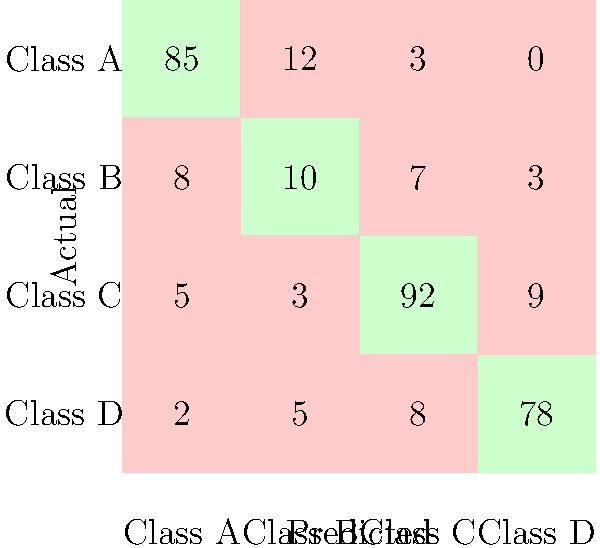As an efficiency-focused software engineer, you're evaluating a multi-class classification model for a critical system component. Given the confusion matrix above, calculate the model's macro-averaged F1 score to assess its overall performance across all classes. How would this metric help in deciding whether to integrate this model or develop a more efficient alternative? To calculate the macro-averaged F1 score, we'll follow these steps:

1. Calculate precision and recall for each class:

Class A:
Precision = 85 / (85 + 12 + 3 + 0) = 0.85
Recall = 85 / (85 + 8 + 5 + 2) = 0.85

Class B:
Precision = 10 / (8 + 10 + 7 + 3) = 0.357
Recall = 10 / (12 + 10 + 3 + 5) = 0.333

Class C:
Precision = 92 / (5 + 3 + 92 + 9) = 0.844
Recall = 92 / (3 + 7 + 92 + 8) = 0.836

Class D:
Precision = 78 / (2 + 5 + 8 + 78) = 0.839
Recall = 78 / (0 + 3 + 9 + 78) = 0.867

2. Calculate F1 score for each class:
F1 = 2 * (Precision * Recall) / (Precision + Recall)

Class A: F1 = 2 * (0.85 * 0.85) / (0.85 + 0.85) = 0.85
Class B: F1 = 2 * (0.357 * 0.333) / (0.357 + 0.333) = 0.345
Class C: F1 = 2 * (0.844 * 0.836) / (0.844 + 0.836) = 0.840
Class D: F1 = 2 * (0.839 * 0.867) / (0.839 + 0.867) = 0.853

3. Calculate macro-averaged F1 score:
Macro-avg F1 = (0.85 + 0.345 + 0.840 + 0.853) / 4 = 0.722

The macro-averaged F1 score of 0.722 provides an overall performance metric that equally weights all classes, regardless of their frequency. This is particularly useful when dealing with imbalanced datasets or when all classes are equally important.

As an efficiency-focused software engineer, this metric helps in deciding whether to integrate this model or develop an alternative by:

1. Providing a single, interpretable metric that summarizes performance across all classes.
2. Highlighting potential areas for improvement, especially for Class B, which has a significantly lower F1 score.
3. Allowing for easy comparison with alternative models or implementations.
4. Helping to set a baseline for performance expectations in the critical system component.

If the current macro-averaged F1 score doesn't meet the required efficiency standards, you might consider:
1. Optimizing the current model using techniques specific to the programming language in use.
2. Exploring alternative algorithms or model architectures that could potentially offer better performance.
3. Investigating whether a different programming language or framework could provide performance benefits for this specific task.
Answer: Macro-averaged F1 score: 0.722. This metric provides a balanced assessment of model performance across all classes, guiding decisions on model integration or the need for more efficient alternatives. 